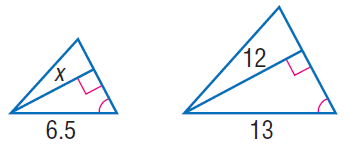Answer the mathemtical geometry problem and directly provide the correct option letter.
Question: Find x.
Choices: A: 6 B: 12 C: 18 D: 24 A 